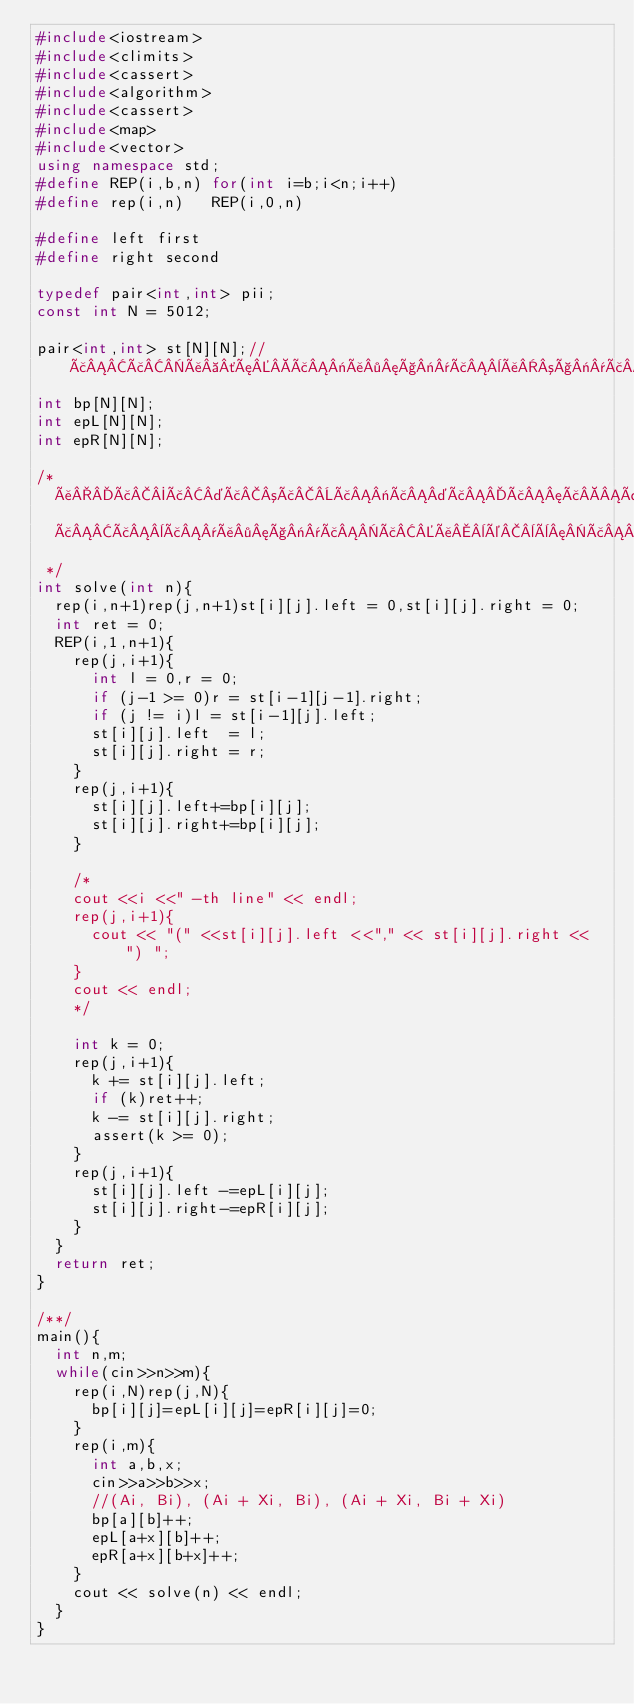<code> <loc_0><loc_0><loc_500><loc_500><_C++_>#include<iostream>
#include<climits>
#include<cassert>
#include<algorithm>
#include<cassert>
#include<map>
#include<vector>
using namespace std;
#define REP(i,b,n) for(int i=b;i<n;i++)
#define rep(i,n)   REP(i,0,n)

#define left first
#define right second

typedef pair<int,int> pii;
const int N = 5012;

pair<int,int> st[N][N];//ããå ´æã«å·¦ç«¯ã¨å³ç«¯ã®ç¹ãä½åããããæ°ããã
int bp[N][N];
int epL[N][N];
int epR[N][N];

/*
  åãã¤ã³ãã«ã¤ãã¦ãä¸è§å½¢ã®å·¦ç«¯ã¨å³ç«¯ããããã¹ã¨ãã®æ°ãè¦ãã¦ããã
  ãã¨ã¯å·¦ç«¯ããå¨é¨è¦ã¦ããã¨ãã®è¡ã®ãã¡ä½åãéãè¼ªã´ã ã«è¦ããã¦ãããããããã
 */
int solve(int n){
  rep(i,n+1)rep(j,n+1)st[i][j].left = 0,st[i][j].right = 0;
  int ret = 0;
  REP(i,1,n+1){
    rep(j,i+1){
      int l = 0,r = 0;
      if (j-1 >= 0)r = st[i-1][j-1].right;
      if (j != i)l = st[i-1][j].left;
      st[i][j].left  = l;
      st[i][j].right = r;
    }
    rep(j,i+1){
      st[i][j].left+=bp[i][j];
      st[i][j].right+=bp[i][j];
    }

    /*
    cout <<i <<" -th line" << endl;
    rep(j,i+1){
      cout << "(" <<st[i][j].left <<"," << st[i][j].right << ") ";
    }
    cout << endl;
    */

    int k = 0;
    rep(j,i+1){
      k += st[i][j].left;
      if (k)ret++;
      k -= st[i][j].right;
      assert(k >= 0);
    }
    rep(j,i+1){
      st[i][j].left -=epL[i][j];
      st[i][j].right-=epR[i][j];
    }
  }
  return ret;
}

/**/
main(){
  int n,m;
  while(cin>>n>>m){
    rep(i,N)rep(j,N){
      bp[i][j]=epL[i][j]=epR[i][j]=0;
    }
    rep(i,m){
      int a,b,x;
      cin>>a>>b>>x;
      //(Ai, Bi), (Ai + Xi, Bi), (Ai + Xi, Bi + Xi) 
      bp[a][b]++;
      epL[a+x][b]++;
      epR[a+x][b+x]++;
    }
    cout << solve(n) << endl;
  }
}</code> 